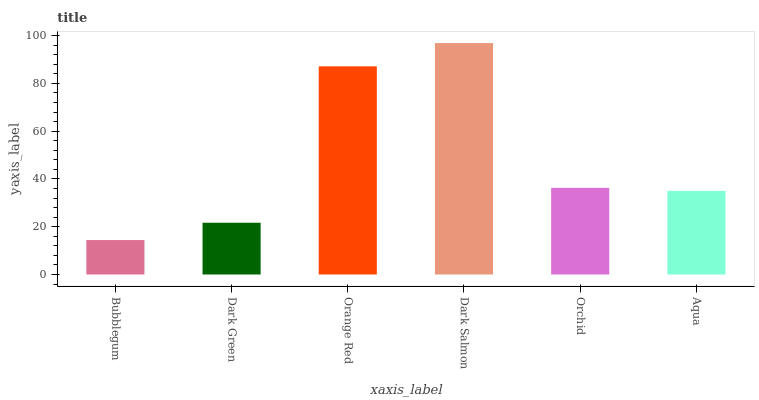Is Bubblegum the minimum?
Answer yes or no. Yes. Is Dark Salmon the maximum?
Answer yes or no. Yes. Is Dark Green the minimum?
Answer yes or no. No. Is Dark Green the maximum?
Answer yes or no. No. Is Dark Green greater than Bubblegum?
Answer yes or no. Yes. Is Bubblegum less than Dark Green?
Answer yes or no. Yes. Is Bubblegum greater than Dark Green?
Answer yes or no. No. Is Dark Green less than Bubblegum?
Answer yes or no. No. Is Orchid the high median?
Answer yes or no. Yes. Is Aqua the low median?
Answer yes or no. Yes. Is Orange Red the high median?
Answer yes or no. No. Is Dark Green the low median?
Answer yes or no. No. 